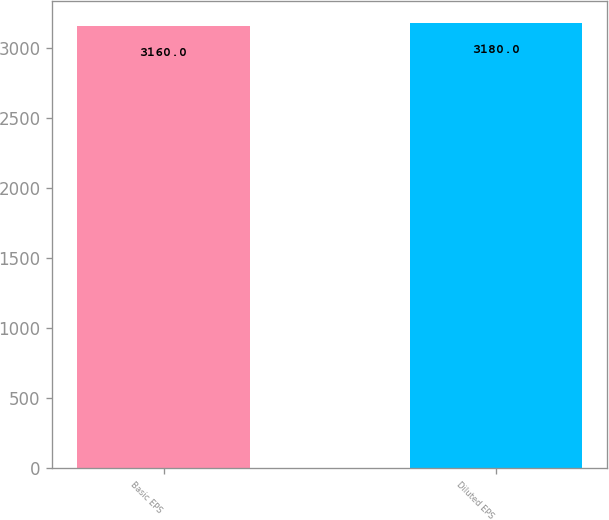<chart> <loc_0><loc_0><loc_500><loc_500><bar_chart><fcel>Basic EPS<fcel>Diluted EPS<nl><fcel>3160<fcel>3180<nl></chart> 